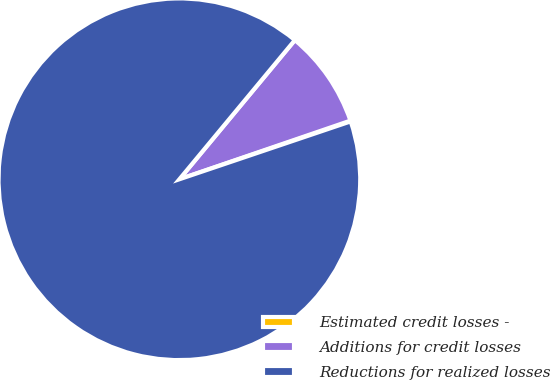Convert chart. <chart><loc_0><loc_0><loc_500><loc_500><pie_chart><fcel>Estimated credit losses -<fcel>Additions for credit losses<fcel>Reductions for realized losses<nl><fcel>0.07%<fcel>8.72%<fcel>91.21%<nl></chart> 